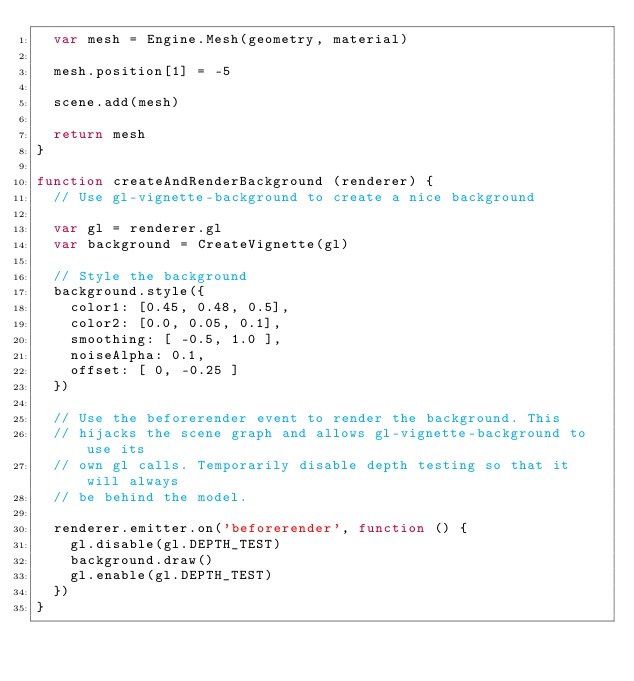Convert code to text. <code><loc_0><loc_0><loc_500><loc_500><_JavaScript_>  var mesh = Engine.Mesh(geometry, material)

  mesh.position[1] = -5

  scene.add(mesh)

  return mesh
}

function createAndRenderBackground (renderer) {
  // Use gl-vignette-background to create a nice background

  var gl = renderer.gl
  var background = CreateVignette(gl)

  // Style the background
  background.style({
    color1: [0.45, 0.48, 0.5],
    color2: [0.0, 0.05, 0.1],
    smoothing: [ -0.5, 1.0 ],
    noiseAlpha: 0.1,
    offset: [ 0, -0.25 ]
  })

  // Use the beforerender event to render the background. This
  // hijacks the scene graph and allows gl-vignette-background to use its
  // own gl calls. Temporarily disable depth testing so that it will always
  // be behind the model.

  renderer.emitter.on('beforerender', function () {
    gl.disable(gl.DEPTH_TEST)
    background.draw()
    gl.enable(gl.DEPTH_TEST)
  })
}
</code> 